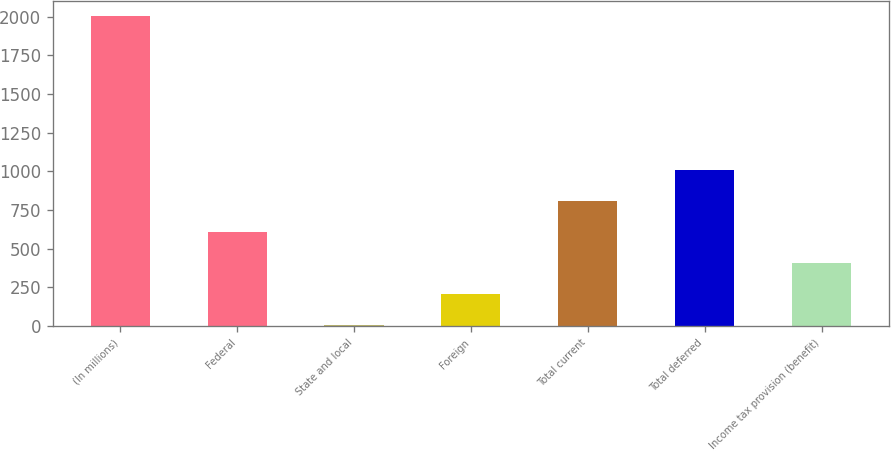Convert chart. <chart><loc_0><loc_0><loc_500><loc_500><bar_chart><fcel>(In millions)<fcel>Federal<fcel>State and local<fcel>Foreign<fcel>Total current<fcel>Total deferred<fcel>Income tax provision (benefit)<nl><fcel>2005<fcel>605.7<fcel>6<fcel>205.9<fcel>805.6<fcel>1005.5<fcel>405.8<nl></chart> 